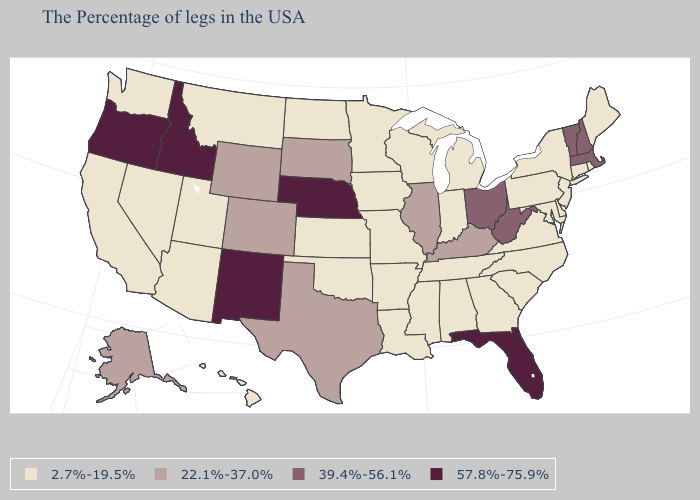Among the states that border Michigan , does Wisconsin have the highest value?
Answer briefly. No. Does Washington have the highest value in the USA?
Write a very short answer. No. What is the value of West Virginia?
Write a very short answer. 39.4%-56.1%. Does the first symbol in the legend represent the smallest category?
Concise answer only. Yes. Does Vermont have the same value as Tennessee?
Short answer required. No. Name the states that have a value in the range 2.7%-19.5%?
Be succinct. Maine, Rhode Island, Connecticut, New York, New Jersey, Delaware, Maryland, Pennsylvania, Virginia, North Carolina, South Carolina, Georgia, Michigan, Indiana, Alabama, Tennessee, Wisconsin, Mississippi, Louisiana, Missouri, Arkansas, Minnesota, Iowa, Kansas, Oklahoma, North Dakota, Utah, Montana, Arizona, Nevada, California, Washington, Hawaii. Among the states that border Tennessee , which have the highest value?
Keep it brief. Kentucky. Does Rhode Island have the same value as Maryland?
Short answer required. Yes. Is the legend a continuous bar?
Quick response, please. No. Among the states that border New Hampshire , does Massachusetts have the lowest value?
Short answer required. No. What is the value of Wisconsin?
Quick response, please. 2.7%-19.5%. What is the value of Ohio?
Answer briefly. 39.4%-56.1%. Does Rhode Island have the same value as Nebraska?
Concise answer only. No. Does Michigan have the lowest value in the USA?
Keep it brief. Yes. Which states have the lowest value in the West?
Give a very brief answer. Utah, Montana, Arizona, Nevada, California, Washington, Hawaii. 